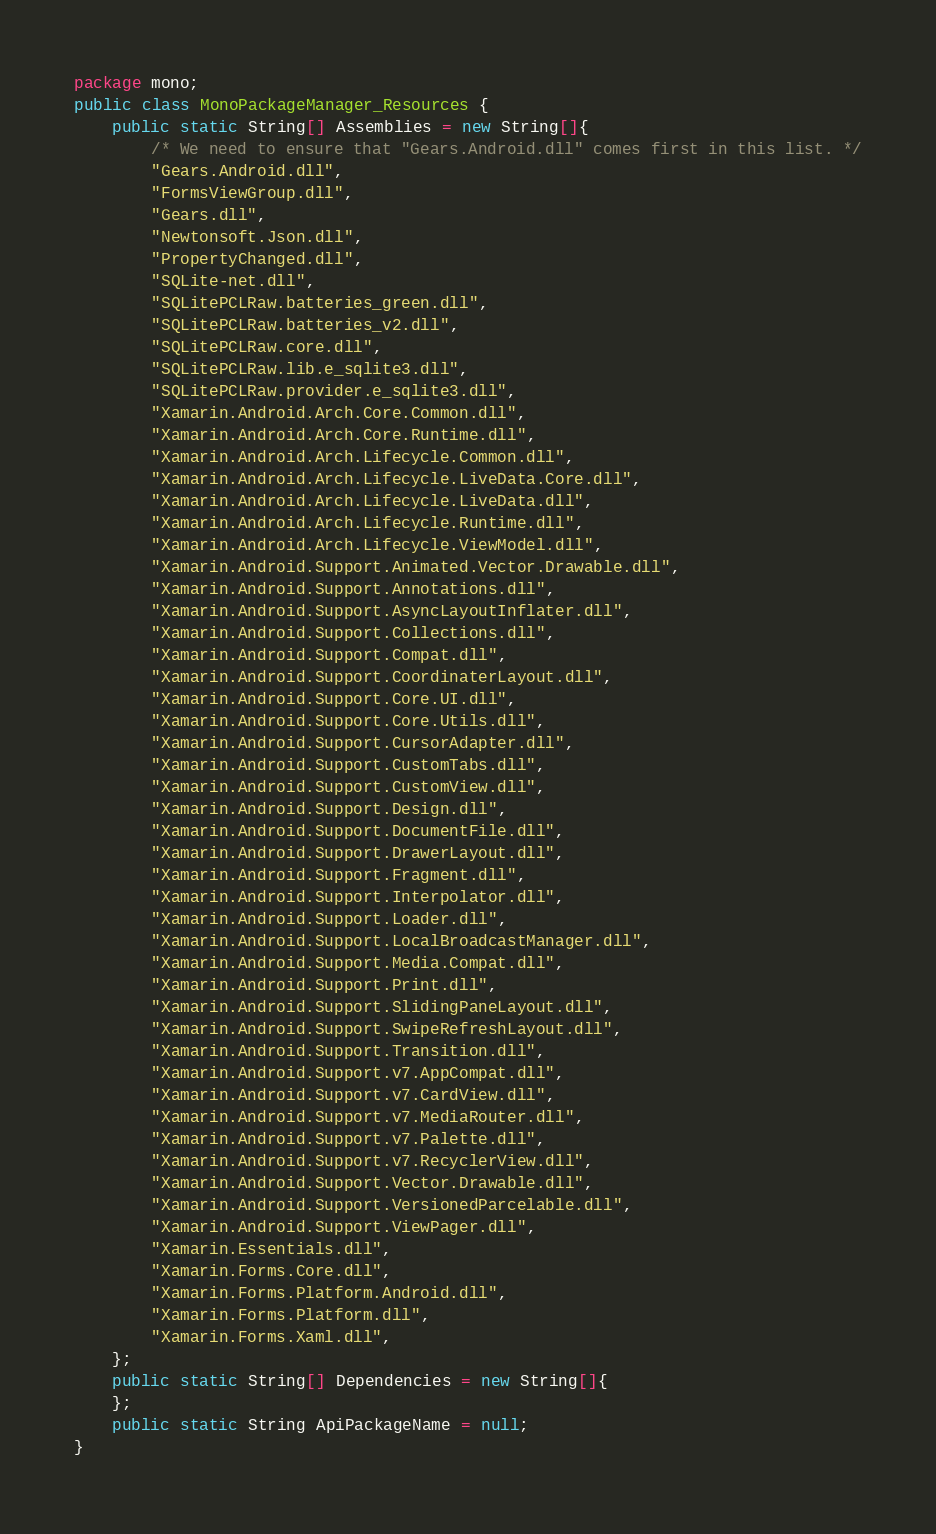<code> <loc_0><loc_0><loc_500><loc_500><_Java_>package mono;
public class MonoPackageManager_Resources {
	public static String[] Assemblies = new String[]{
		/* We need to ensure that "Gears.Android.dll" comes first in this list. */
		"Gears.Android.dll",
		"FormsViewGroup.dll",
		"Gears.dll",
		"Newtonsoft.Json.dll",
		"PropertyChanged.dll",
		"SQLite-net.dll",
		"SQLitePCLRaw.batteries_green.dll",
		"SQLitePCLRaw.batteries_v2.dll",
		"SQLitePCLRaw.core.dll",
		"SQLitePCLRaw.lib.e_sqlite3.dll",
		"SQLitePCLRaw.provider.e_sqlite3.dll",
		"Xamarin.Android.Arch.Core.Common.dll",
		"Xamarin.Android.Arch.Core.Runtime.dll",
		"Xamarin.Android.Arch.Lifecycle.Common.dll",
		"Xamarin.Android.Arch.Lifecycle.LiveData.Core.dll",
		"Xamarin.Android.Arch.Lifecycle.LiveData.dll",
		"Xamarin.Android.Arch.Lifecycle.Runtime.dll",
		"Xamarin.Android.Arch.Lifecycle.ViewModel.dll",
		"Xamarin.Android.Support.Animated.Vector.Drawable.dll",
		"Xamarin.Android.Support.Annotations.dll",
		"Xamarin.Android.Support.AsyncLayoutInflater.dll",
		"Xamarin.Android.Support.Collections.dll",
		"Xamarin.Android.Support.Compat.dll",
		"Xamarin.Android.Support.CoordinaterLayout.dll",
		"Xamarin.Android.Support.Core.UI.dll",
		"Xamarin.Android.Support.Core.Utils.dll",
		"Xamarin.Android.Support.CursorAdapter.dll",
		"Xamarin.Android.Support.CustomTabs.dll",
		"Xamarin.Android.Support.CustomView.dll",
		"Xamarin.Android.Support.Design.dll",
		"Xamarin.Android.Support.DocumentFile.dll",
		"Xamarin.Android.Support.DrawerLayout.dll",
		"Xamarin.Android.Support.Fragment.dll",
		"Xamarin.Android.Support.Interpolator.dll",
		"Xamarin.Android.Support.Loader.dll",
		"Xamarin.Android.Support.LocalBroadcastManager.dll",
		"Xamarin.Android.Support.Media.Compat.dll",
		"Xamarin.Android.Support.Print.dll",
		"Xamarin.Android.Support.SlidingPaneLayout.dll",
		"Xamarin.Android.Support.SwipeRefreshLayout.dll",
		"Xamarin.Android.Support.Transition.dll",
		"Xamarin.Android.Support.v7.AppCompat.dll",
		"Xamarin.Android.Support.v7.CardView.dll",
		"Xamarin.Android.Support.v7.MediaRouter.dll",
		"Xamarin.Android.Support.v7.Palette.dll",
		"Xamarin.Android.Support.v7.RecyclerView.dll",
		"Xamarin.Android.Support.Vector.Drawable.dll",
		"Xamarin.Android.Support.VersionedParcelable.dll",
		"Xamarin.Android.Support.ViewPager.dll",
		"Xamarin.Essentials.dll",
		"Xamarin.Forms.Core.dll",
		"Xamarin.Forms.Platform.Android.dll",
		"Xamarin.Forms.Platform.dll",
		"Xamarin.Forms.Xaml.dll",
	};
	public static String[] Dependencies = new String[]{
	};
	public static String ApiPackageName = null;
}
</code> 